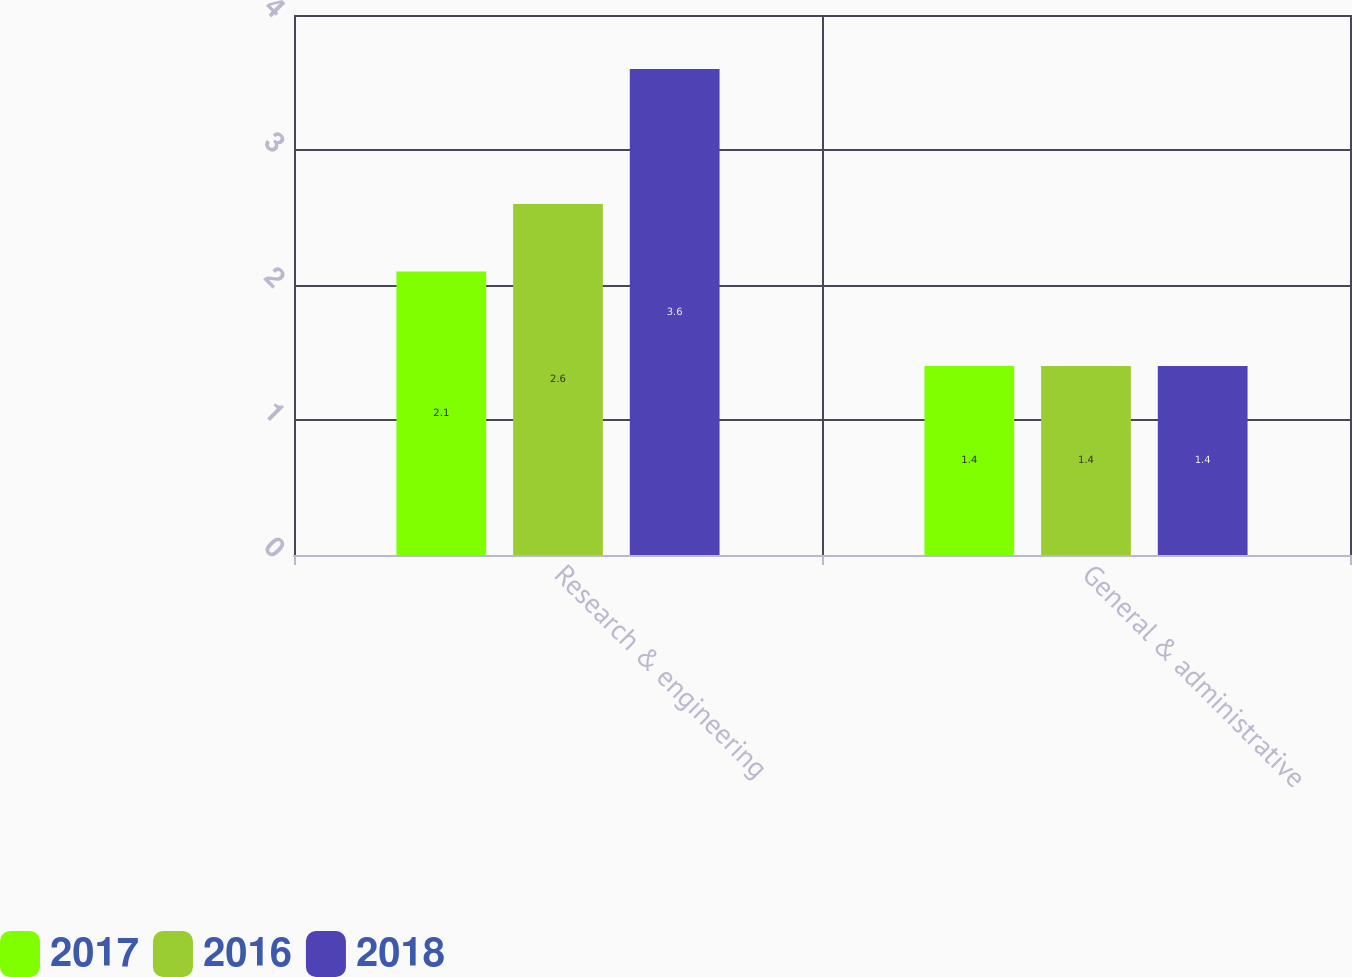Convert chart. <chart><loc_0><loc_0><loc_500><loc_500><stacked_bar_chart><ecel><fcel>Research & engineering<fcel>General & administrative<nl><fcel>2017<fcel>2.1<fcel>1.4<nl><fcel>2016<fcel>2.6<fcel>1.4<nl><fcel>2018<fcel>3.6<fcel>1.4<nl></chart> 